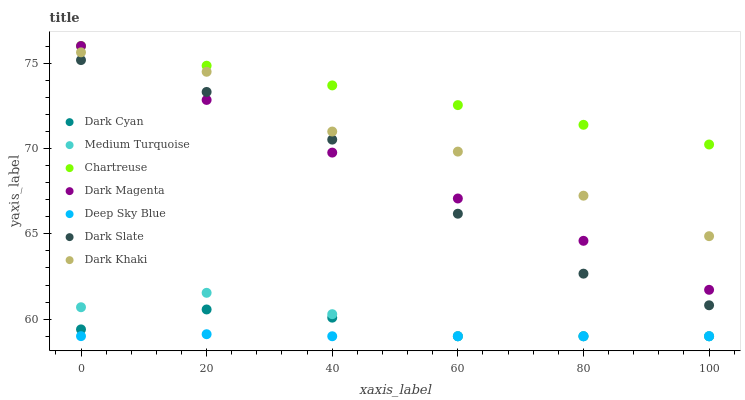Does Deep Sky Blue have the minimum area under the curve?
Answer yes or no. Yes. Does Chartreuse have the maximum area under the curve?
Answer yes or no. Yes. Does Dark Magenta have the minimum area under the curve?
Answer yes or no. No. Does Dark Magenta have the maximum area under the curve?
Answer yes or no. No. Is Chartreuse the smoothest?
Answer yes or no. Yes. Is Dark Khaki the roughest?
Answer yes or no. Yes. Is Dark Magenta the smoothest?
Answer yes or no. No. Is Dark Magenta the roughest?
Answer yes or no. No. Does Medium Turquoise have the lowest value?
Answer yes or no. Yes. Does Dark Magenta have the lowest value?
Answer yes or no. No. Does Chartreuse have the highest value?
Answer yes or no. Yes. Does Dark Khaki have the highest value?
Answer yes or no. No. Is Dark Cyan less than Dark Magenta?
Answer yes or no. Yes. Is Dark Magenta greater than Medium Turquoise?
Answer yes or no. Yes. Does Medium Turquoise intersect Dark Cyan?
Answer yes or no. Yes. Is Medium Turquoise less than Dark Cyan?
Answer yes or no. No. Is Medium Turquoise greater than Dark Cyan?
Answer yes or no. No. Does Dark Cyan intersect Dark Magenta?
Answer yes or no. No. 